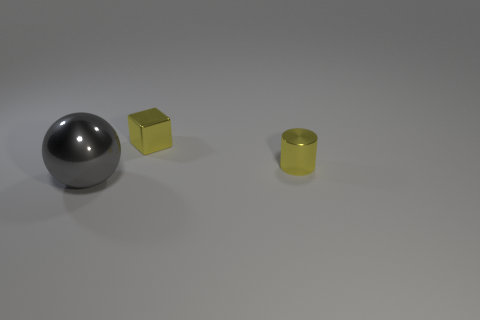Are there any other things that have the same size as the gray shiny thing?
Provide a succinct answer. No. How many large objects are to the left of the big metal sphere?
Your answer should be very brief. 0. Are there fewer tiny metal things left of the yellow metal cube than green spheres?
Give a very brief answer. No. What color is the big metallic ball?
Offer a very short reply. Gray. Is the color of the small object to the left of the yellow cylinder the same as the sphere?
Keep it short and to the point. No. How many tiny objects are either metal spheres or cyan metallic cylinders?
Ensure brevity in your answer.  0. What is the size of the yellow object that is on the right side of the small block?
Give a very brief answer. Small. Are there any metal things that have the same color as the tiny cube?
Your answer should be compact. Yes. Is the metallic cube the same color as the big thing?
Offer a terse response. No. What is the shape of the metal thing that is the same color as the shiny cube?
Ensure brevity in your answer.  Cylinder. 